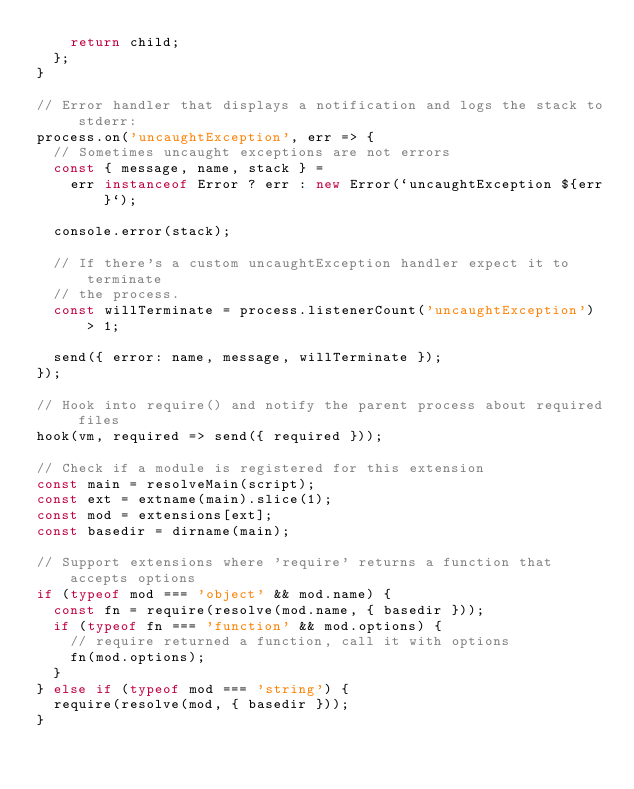<code> <loc_0><loc_0><loc_500><loc_500><_JavaScript_>    return child;
  };
}

// Error handler that displays a notification and logs the stack to stderr:
process.on('uncaughtException', err => {
  // Sometimes uncaught exceptions are not errors
  const { message, name, stack } =
    err instanceof Error ? err : new Error(`uncaughtException ${err}`);

  console.error(stack);

  // If there's a custom uncaughtException handler expect it to terminate
  // the process.
  const willTerminate = process.listenerCount('uncaughtException') > 1;

  send({ error: name, message, willTerminate });
});

// Hook into require() and notify the parent process about required files
hook(vm, required => send({ required }));

// Check if a module is registered for this extension
const main = resolveMain(script);
const ext = extname(main).slice(1);
const mod = extensions[ext];
const basedir = dirname(main);

// Support extensions where 'require' returns a function that accepts options
if (typeof mod === 'object' && mod.name) {
  const fn = require(resolve(mod.name, { basedir }));
  if (typeof fn === 'function' && mod.options) {
    // require returned a function, call it with options
    fn(mod.options);
  }
} else if (typeof mod === 'string') {
  require(resolve(mod, { basedir }));
}
</code> 